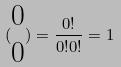Convert formula to latex. <formula><loc_0><loc_0><loc_500><loc_500>( \begin{matrix} 0 \\ 0 \end{matrix} ) = \frac { 0 ! } { 0 ! 0 ! } = 1</formula> 